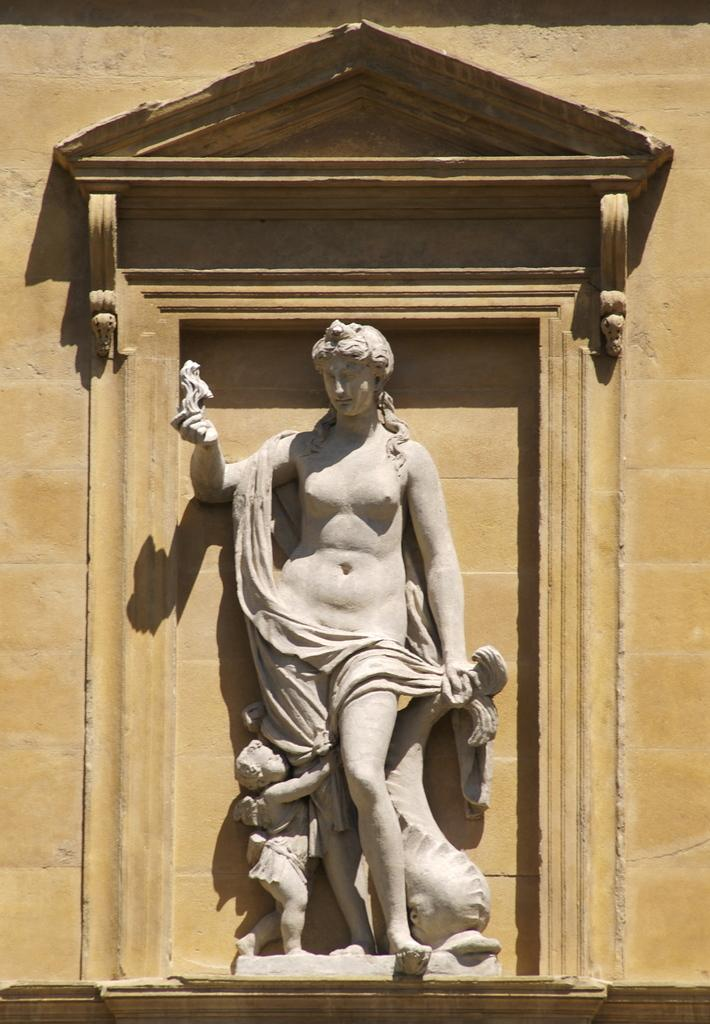What is the main subject of the image? The main subject of the image is a statue of a woman and child. What else can be seen in the image? There is a wall visible in the image. How many frogs are sitting on the statue in the image? There are no frogs present in the image; it features a statue of a woman and child. What type of territory is depicted in the image? The image does not depict any specific territory; it only shows a statue and a wall. 